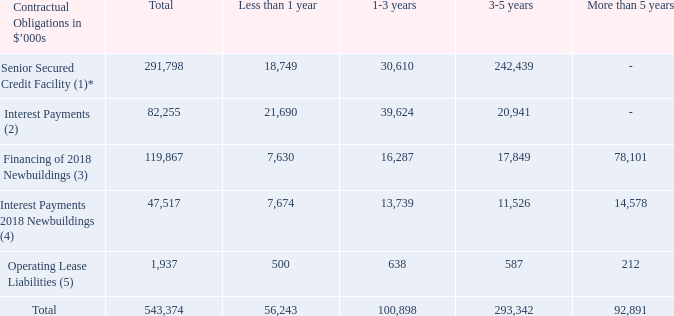The Company’s contractual obligations as of December 31, 2019, consist of our obligations as borrower under our 2019 Senior Secured Credit Facility, our obligations related to financing of our three 2018 Newbuildings.
The following table sets out financial, commercial and other obligations outstanding as of December 31, 2019.
Notes:
(1) Refers to obligation to repay indebtedness outstanding as of December 31, 2019.
(2) Refers to estimated interest payments over the term of the indebtedness outstanding as of December 31, 2019. Estimate based on applicable interest rate and drawn amount as of December 31, 2019.
(3) Refers to obligation to repay indebtedness outstanding as of December 31, 2019 for three 2018 Newbuildings.
(4) Refers to estimated interest payments over the term of the indebtedness outstanding as of December 31, 2019. Estimate based on applicable interest as of December 31, 2019 for the financing of the three 2018 Newbuildings.
(5) Refers to the future obligation as of December 31, 2019 to pay for operating lease liabilities at nominal values.
*The new five-year senior secured credit facility for $306.1 million is amortizing with a twenty-year maturity profile, carries a floating LIBOR interest rate plus a margin and matures in February 2024. Further, the agreement contains a discretionary excess cash amortization mechanism for the lender that equals 50% of the net earnings from the collateral vessels, less capex provision and fixed amortization.
What does Senior Secured Credit Facility refer to? Obligation to repay indebtedness outstanding as of december 31, 2019. What does Interest Payments refer to? Estimated interest payments over the term of the indebtedness outstanding as of december 31, 2019. What does Financing of 2018 Newbuildings refer to? Obligation to repay indebtedness outstanding as of december 31, 2019 for three 2018 newbuildings. What is the average total Senior Secured Credit Facility and Interest Payments?
Answer scale should be: thousand. (291,798 + 82,255)/2 
Answer: 187026.5. What is the average total Interest Payments and Financing of 2018 Newbuildings?
Answer scale should be: thousand. (82,255 + 119,867)/2 
Answer: 101061. What is the total average Financing of 2018 Newbuildings and Interest Payments 2018 Newbuildings?
Answer scale should be: thousand. (119,867 + 47,517)/2 
Answer: 83692. 